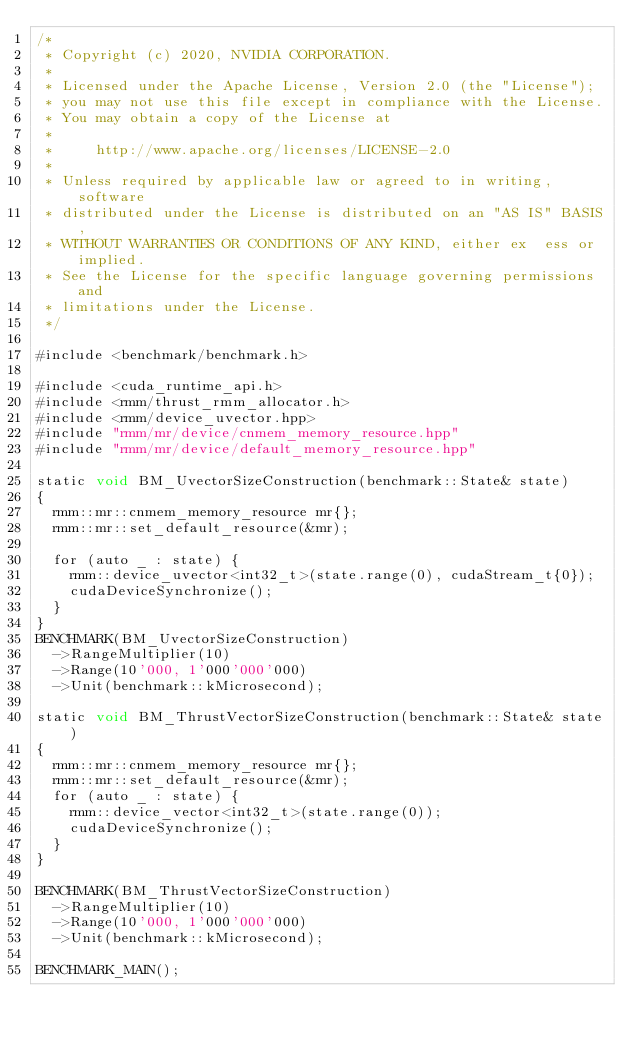<code> <loc_0><loc_0><loc_500><loc_500><_Cuda_>/*
 * Copyright (c) 2020, NVIDIA CORPORATION.
 *
 * Licensed under the Apache License, Version 2.0 (the "License");
 * you may not use this file except in compliance with the License.
 * You may obtain a copy of the License at
 *
 *     http://www.apache.org/licenses/LICENSE-2.0
 *
 * Unless required by applicable law or agreed to in writing, software
 * distributed under the License is distributed on an "AS IS" BASIS,
 * WITHOUT WARRANTIES OR CONDITIONS OF ANY KIND, either ex  ess or implied.
 * See the License for the specific language governing permissions and
 * limitations under the License.
 */

#include <benchmark/benchmark.h>

#include <cuda_runtime_api.h>
#include <rmm/thrust_rmm_allocator.h>
#include <rmm/device_uvector.hpp>
#include "rmm/mr/device/cnmem_memory_resource.hpp"
#include "rmm/mr/device/default_memory_resource.hpp"

static void BM_UvectorSizeConstruction(benchmark::State& state)
{
  rmm::mr::cnmem_memory_resource mr{};
  rmm::mr::set_default_resource(&mr);

  for (auto _ : state) {
    rmm::device_uvector<int32_t>(state.range(0), cudaStream_t{0});
    cudaDeviceSynchronize();
  }
}
BENCHMARK(BM_UvectorSizeConstruction)
  ->RangeMultiplier(10)
  ->Range(10'000, 1'000'000'000)
  ->Unit(benchmark::kMicrosecond);

static void BM_ThrustVectorSizeConstruction(benchmark::State& state)
{
  rmm::mr::cnmem_memory_resource mr{};
  rmm::mr::set_default_resource(&mr);
  for (auto _ : state) {
    rmm::device_vector<int32_t>(state.range(0));
    cudaDeviceSynchronize();
  }
}

BENCHMARK(BM_ThrustVectorSizeConstruction)
  ->RangeMultiplier(10)
  ->Range(10'000, 1'000'000'000)
  ->Unit(benchmark::kMicrosecond);

BENCHMARK_MAIN();
</code> 